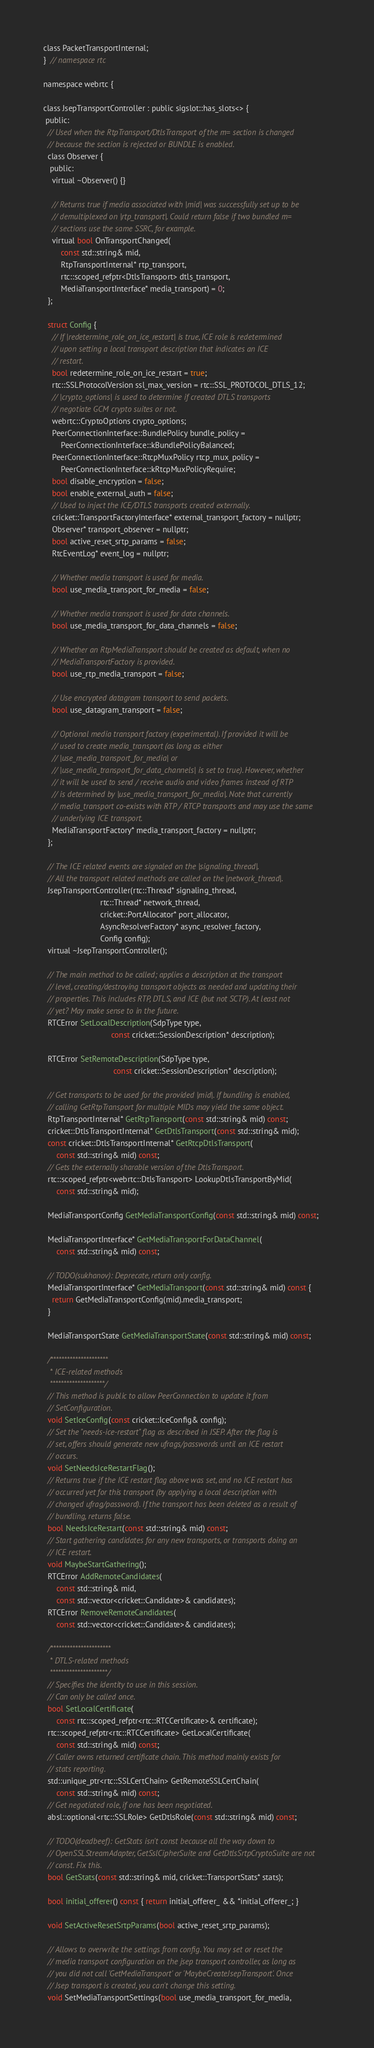<code> <loc_0><loc_0><loc_500><loc_500><_C_>class PacketTransportInternal;
}  // namespace rtc

namespace webrtc {

class JsepTransportController : public sigslot::has_slots<> {
 public:
  // Used when the RtpTransport/DtlsTransport of the m= section is changed
  // because the section is rejected or BUNDLE is enabled.
  class Observer {
   public:
    virtual ~Observer() {}

    // Returns true if media associated with |mid| was successfully set up to be
    // demultiplexed on |rtp_transport|. Could return false if two bundled m=
    // sections use the same SSRC, for example.
    virtual bool OnTransportChanged(
        const std::string& mid,
        RtpTransportInternal* rtp_transport,
        rtc::scoped_refptr<DtlsTransport> dtls_transport,
        MediaTransportInterface* media_transport) = 0;
  };

  struct Config {
    // If |redetermine_role_on_ice_restart| is true, ICE role is redetermined
    // upon setting a local transport description that indicates an ICE
    // restart.
    bool redetermine_role_on_ice_restart = true;
    rtc::SSLProtocolVersion ssl_max_version = rtc::SSL_PROTOCOL_DTLS_12;
    // |crypto_options| is used to determine if created DTLS transports
    // negotiate GCM crypto suites or not.
    webrtc::CryptoOptions crypto_options;
    PeerConnectionInterface::BundlePolicy bundle_policy =
        PeerConnectionInterface::kBundlePolicyBalanced;
    PeerConnectionInterface::RtcpMuxPolicy rtcp_mux_policy =
        PeerConnectionInterface::kRtcpMuxPolicyRequire;
    bool disable_encryption = false;
    bool enable_external_auth = false;
    // Used to inject the ICE/DTLS transports created externally.
    cricket::TransportFactoryInterface* external_transport_factory = nullptr;
    Observer* transport_observer = nullptr;
    bool active_reset_srtp_params = false;
    RtcEventLog* event_log = nullptr;

    // Whether media transport is used for media.
    bool use_media_transport_for_media = false;

    // Whether media transport is used for data channels.
    bool use_media_transport_for_data_channels = false;

    // Whether an RtpMediaTransport should be created as default, when no
    // MediaTransportFactory is provided.
    bool use_rtp_media_transport = false;

    // Use encrypted datagram transport to send packets.
    bool use_datagram_transport = false;

    // Optional media transport factory (experimental). If provided it will be
    // used to create media_transport (as long as either
    // |use_media_transport_for_media| or
    // |use_media_transport_for_data_channels| is set to true). However, whether
    // it will be used to send / receive audio and video frames instead of RTP
    // is determined by |use_media_transport_for_media|. Note that currently
    // media_transport co-exists with RTP / RTCP transports and may use the same
    // underlying ICE transport.
    MediaTransportFactory* media_transport_factory = nullptr;
  };

  // The ICE related events are signaled on the |signaling_thread|.
  // All the transport related methods are called on the |network_thread|.
  JsepTransportController(rtc::Thread* signaling_thread,
                          rtc::Thread* network_thread,
                          cricket::PortAllocator* port_allocator,
                          AsyncResolverFactory* async_resolver_factory,
                          Config config);
  virtual ~JsepTransportController();

  // The main method to be called; applies a description at the transport
  // level, creating/destroying transport objects as needed and updating their
  // properties. This includes RTP, DTLS, and ICE (but not SCTP). At least not
  // yet? May make sense to in the future.
  RTCError SetLocalDescription(SdpType type,
                               const cricket::SessionDescription* description);

  RTCError SetRemoteDescription(SdpType type,
                                const cricket::SessionDescription* description);

  // Get transports to be used for the provided |mid|. If bundling is enabled,
  // calling GetRtpTransport for multiple MIDs may yield the same object.
  RtpTransportInternal* GetRtpTransport(const std::string& mid) const;
  cricket::DtlsTransportInternal* GetDtlsTransport(const std::string& mid);
  const cricket::DtlsTransportInternal* GetRtcpDtlsTransport(
      const std::string& mid) const;
  // Gets the externally sharable version of the DtlsTransport.
  rtc::scoped_refptr<webrtc::DtlsTransport> LookupDtlsTransportByMid(
      const std::string& mid);

  MediaTransportConfig GetMediaTransportConfig(const std::string& mid) const;

  MediaTransportInterface* GetMediaTransportForDataChannel(
      const std::string& mid) const;

  // TODO(sukhanov): Deprecate, return only config.
  MediaTransportInterface* GetMediaTransport(const std::string& mid) const {
    return GetMediaTransportConfig(mid).media_transport;
  }

  MediaTransportState GetMediaTransportState(const std::string& mid) const;

  /*********************
   * ICE-related methods
   ********************/
  // This method is public to allow PeerConnection to update it from
  // SetConfiguration.
  void SetIceConfig(const cricket::IceConfig& config);
  // Set the "needs-ice-restart" flag as described in JSEP. After the flag is
  // set, offers should generate new ufrags/passwords until an ICE restart
  // occurs.
  void SetNeedsIceRestartFlag();
  // Returns true if the ICE restart flag above was set, and no ICE restart has
  // occurred yet for this transport (by applying a local description with
  // changed ufrag/password). If the transport has been deleted as a result of
  // bundling, returns false.
  bool NeedsIceRestart(const std::string& mid) const;
  // Start gathering candidates for any new transports, or transports doing an
  // ICE restart.
  void MaybeStartGathering();
  RTCError AddRemoteCandidates(
      const std::string& mid,
      const std::vector<cricket::Candidate>& candidates);
  RTCError RemoveRemoteCandidates(
      const std::vector<cricket::Candidate>& candidates);

  /**********************
   * DTLS-related methods
   *********************/
  // Specifies the identity to use in this session.
  // Can only be called once.
  bool SetLocalCertificate(
      const rtc::scoped_refptr<rtc::RTCCertificate>& certificate);
  rtc::scoped_refptr<rtc::RTCCertificate> GetLocalCertificate(
      const std::string& mid) const;
  // Caller owns returned certificate chain. This method mainly exists for
  // stats reporting.
  std::unique_ptr<rtc::SSLCertChain> GetRemoteSSLCertChain(
      const std::string& mid) const;
  // Get negotiated role, if one has been negotiated.
  absl::optional<rtc::SSLRole> GetDtlsRole(const std::string& mid) const;

  // TODO(deadbeef): GetStats isn't const because all the way down to
  // OpenSSLStreamAdapter, GetSslCipherSuite and GetDtlsSrtpCryptoSuite are not
  // const. Fix this.
  bool GetStats(const std::string& mid, cricket::TransportStats* stats);

  bool initial_offerer() const { return initial_offerer_ && *initial_offerer_; }

  void SetActiveResetSrtpParams(bool active_reset_srtp_params);

  // Allows to overwrite the settings from config. You may set or reset the
  // media transport configuration on the jsep transport controller, as long as
  // you did not call 'GetMediaTransport' or 'MaybeCreateJsepTransport'. Once
  // Jsep transport is created, you can't change this setting.
  void SetMediaTransportSettings(bool use_media_transport_for_media,</code> 